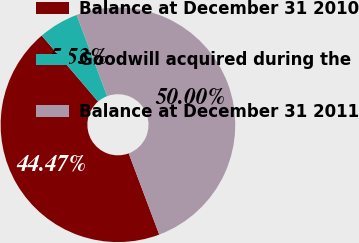Convert chart to OTSL. <chart><loc_0><loc_0><loc_500><loc_500><pie_chart><fcel>Balance at December 31 2010<fcel>Goodwill acquired during the<fcel>Balance at December 31 2011<nl><fcel>44.47%<fcel>5.53%<fcel>50.0%<nl></chart> 